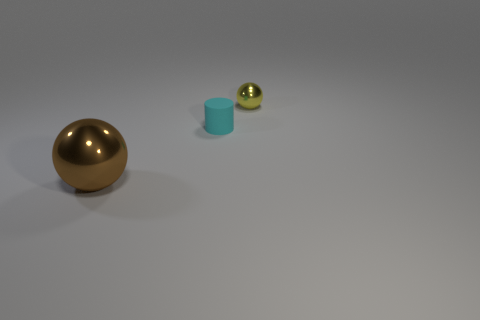Add 2 tiny blue metallic blocks. How many objects exist? 5 Subtract all balls. How many objects are left? 1 Subtract all small purple metallic cubes. Subtract all cyan rubber objects. How many objects are left? 2 Add 1 tiny yellow metal spheres. How many tiny yellow metal spheres are left? 2 Add 2 yellow spheres. How many yellow spheres exist? 3 Subtract 1 brown balls. How many objects are left? 2 